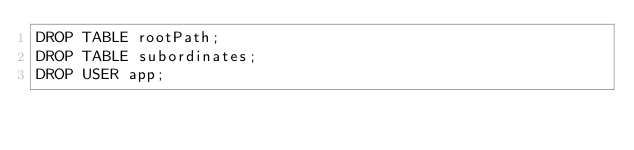Convert code to text. <code><loc_0><loc_0><loc_500><loc_500><_SQL_>DROP TABLE rootPath;
DROP TABLE subordinates;
DROP USER app;</code> 